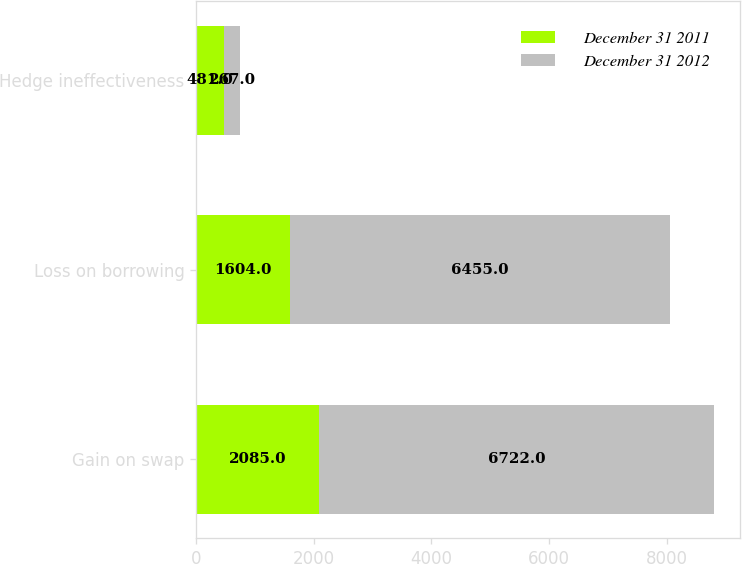Convert chart to OTSL. <chart><loc_0><loc_0><loc_500><loc_500><stacked_bar_chart><ecel><fcel>Gain on swap<fcel>Loss on borrowing<fcel>Hedge ineffectiveness<nl><fcel>December 31 2011<fcel>2085<fcel>1604<fcel>481<nl><fcel>December 31 2012<fcel>6722<fcel>6455<fcel>267<nl></chart> 